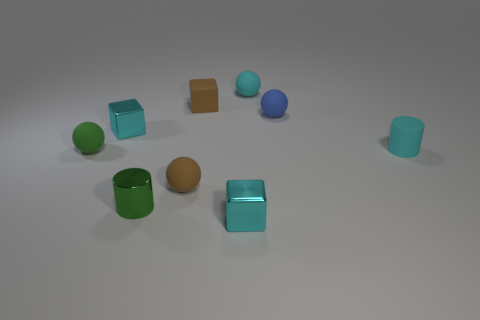How many other things are the same size as the rubber cube?
Keep it short and to the point. 8. What is the size of the metallic object that is behind the tiny green rubber thing?
Provide a short and direct response. Small. How many other tiny blocks have the same material as the brown cube?
Offer a terse response. 0. Do the tiny brown matte thing behind the small blue object and the small green metal thing have the same shape?
Keep it short and to the point. No. There is a tiny cyan thing that is in front of the small cyan rubber cylinder; what shape is it?
Give a very brief answer. Cube. What is the size of the thing that is the same color as the tiny rubber block?
Your answer should be very brief. Small. What is the material of the blue thing?
Your answer should be very brief. Rubber. There is a rubber cylinder that is the same size as the blue matte sphere; what color is it?
Your response must be concise. Cyan. What shape is the matte object that is the same color as the small matte cylinder?
Offer a terse response. Sphere. Is the small blue thing the same shape as the green matte thing?
Your answer should be compact. Yes. 